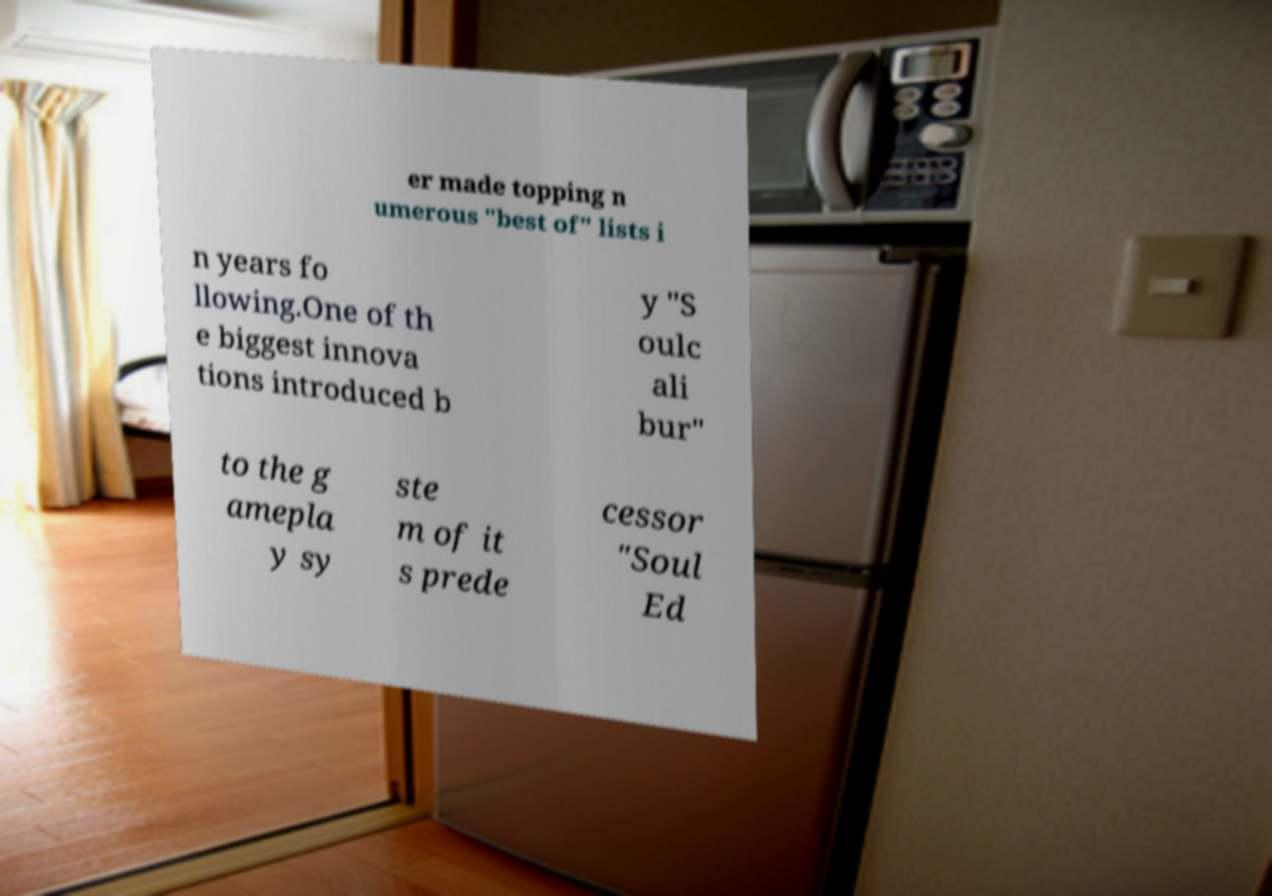Please read and relay the text visible in this image. What does it say? er made topping n umerous "best of" lists i n years fo llowing.One of th e biggest innova tions introduced b y "S oulc ali bur" to the g amepla y sy ste m of it s prede cessor "Soul Ed 